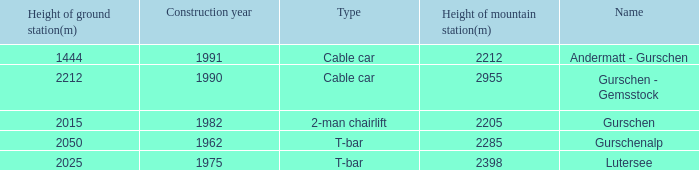How much Height of ground station(m) has a Name of lutersee, and a Height of mountain station(m) larger than 2398? 0.0. 